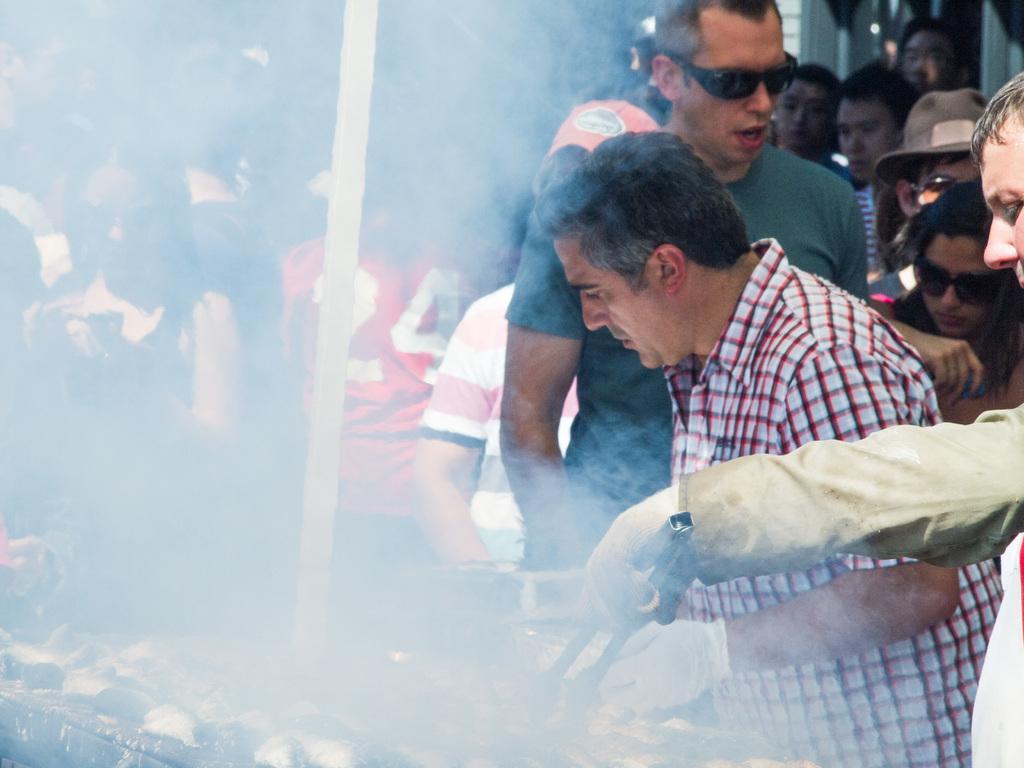Describe this image in one or two sentences. On the right side of the image there is a person holding the tongue. In front of him there are food items on the grill. Beside him there are a few other people. 